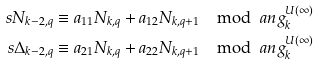Convert formula to latex. <formula><loc_0><loc_0><loc_500><loc_500>s N _ { k - 2 , q } & \equiv a _ { 1 1 } N _ { k , q } + a _ { 1 2 } N _ { k , q + 1 } \mod \ a n g ^ { U ( \infty ) } _ { k } \\ s \Delta _ { k - 2 , q } & \equiv a _ { 2 1 } N _ { k , q } + a _ { 2 2 } N _ { k , q + 1 } \mod \ a n g ^ { U ( \infty ) } _ { k }</formula> 